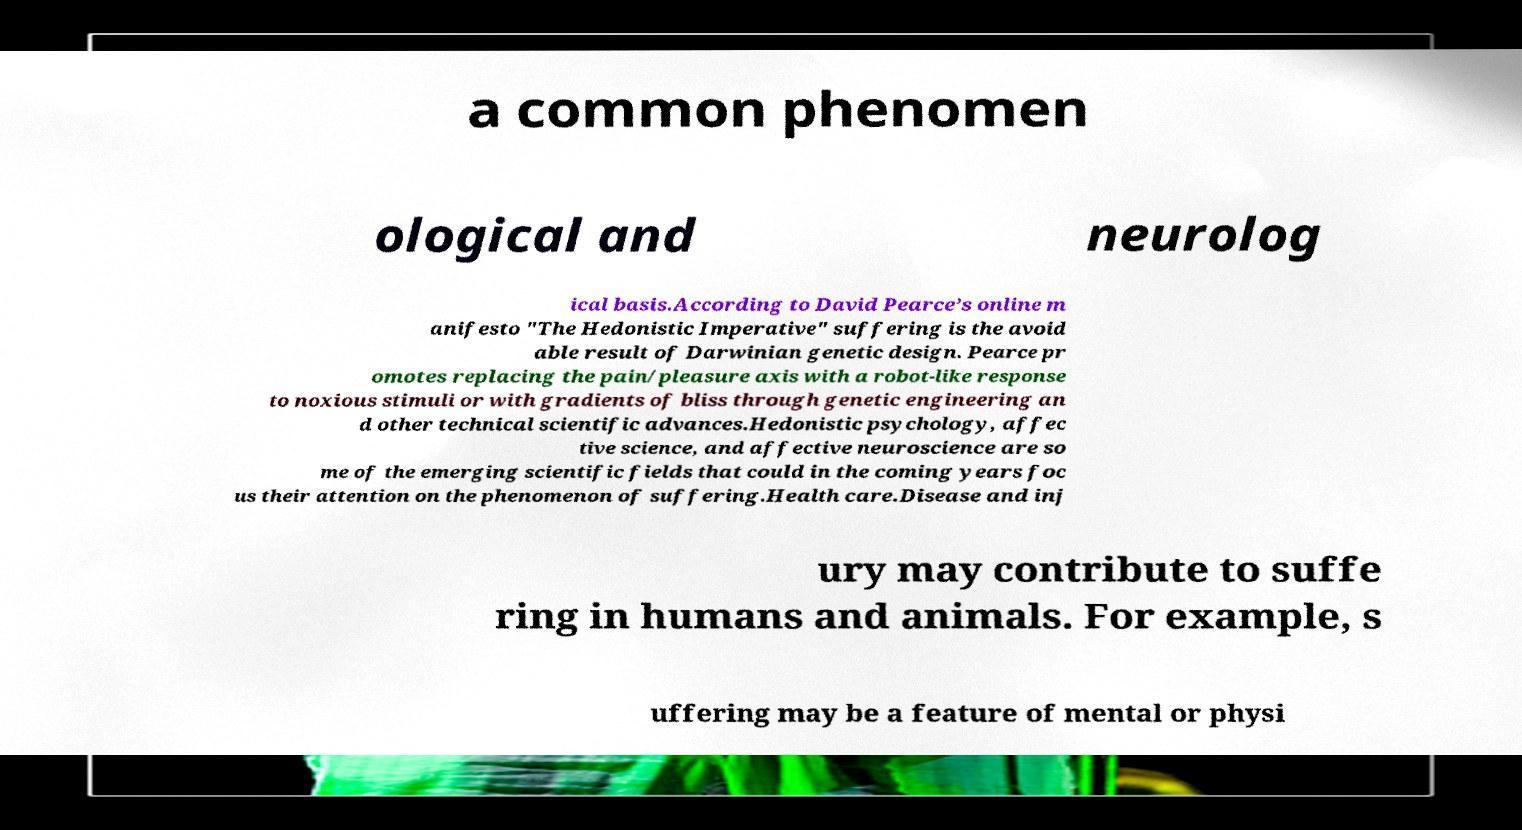Can you accurately transcribe the text from the provided image for me? a common phenomen ological and neurolog ical basis.According to David Pearce’s online m anifesto "The Hedonistic Imperative" suffering is the avoid able result of Darwinian genetic design. Pearce pr omotes replacing the pain/pleasure axis with a robot-like response to noxious stimuli or with gradients of bliss through genetic engineering an d other technical scientific advances.Hedonistic psychology, affec tive science, and affective neuroscience are so me of the emerging scientific fields that could in the coming years foc us their attention on the phenomenon of suffering.Health care.Disease and inj ury may contribute to suffe ring in humans and animals. For example, s uffering may be a feature of mental or physi 